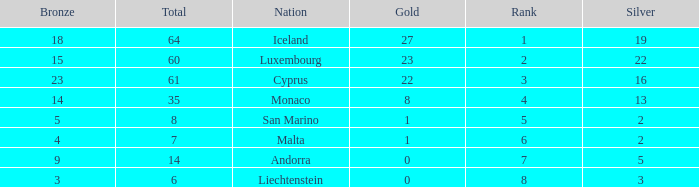Could you parse the entire table as a dict? {'header': ['Bronze', 'Total', 'Nation', 'Gold', 'Rank', 'Silver'], 'rows': [['18', '64', 'Iceland', '27', '1', '19'], ['15', '60', 'Luxembourg', '23', '2', '22'], ['23', '61', 'Cyprus', '22', '3', '16'], ['14', '35', 'Monaco', '8', '4', '13'], ['5', '8', 'San Marino', '1', '5', '2'], ['4', '7', 'Malta', '1', '6', '2'], ['9', '14', 'Andorra', '0', '7', '5'], ['3', '6', 'Liechtenstein', '0', '8', '3']]} How many golds for the nation with 14 total? 0.0. 